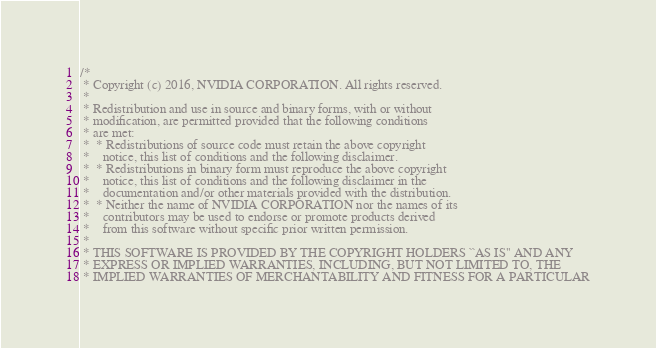Convert code to text. <code><loc_0><loc_0><loc_500><loc_500><_Cuda_>/*
 * Copyright (c) 2016, NVIDIA CORPORATION. All rights reserved.
 *
 * Redistribution and use in source and binary forms, with or without
 * modification, are permitted provided that the following conditions
 * are met:
 *  * Redistributions of source code must retain the above copyright
 *    notice, this list of conditions and the following disclaimer.
 *  * Redistributions in binary form must reproduce the above copyright
 *    notice, this list of conditions and the following disclaimer in the
 *    documentation and/or other materials provided with the distribution.
 *  * Neither the name of NVIDIA CORPORATION nor the names of its
 *    contributors may be used to endorse or promote products derived
 *    from this software without specific prior written permission.
 *
 * THIS SOFTWARE IS PROVIDED BY THE COPYRIGHT HOLDERS ``AS IS'' AND ANY
 * EXPRESS OR IMPLIED WARRANTIES, INCLUDING, BUT NOT LIMITED TO, THE
 * IMPLIED WARRANTIES OF MERCHANTABILITY AND FITNESS FOR A PARTICULAR</code> 